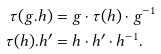<formula> <loc_0><loc_0><loc_500><loc_500>\tau ( g . h ) & = g \cdot \tau ( h ) \cdot g ^ { - 1 } \\ \tau ( h ) . h ^ { \prime } & = h \cdot h ^ { \prime } \cdot h ^ { - 1 } .</formula> 